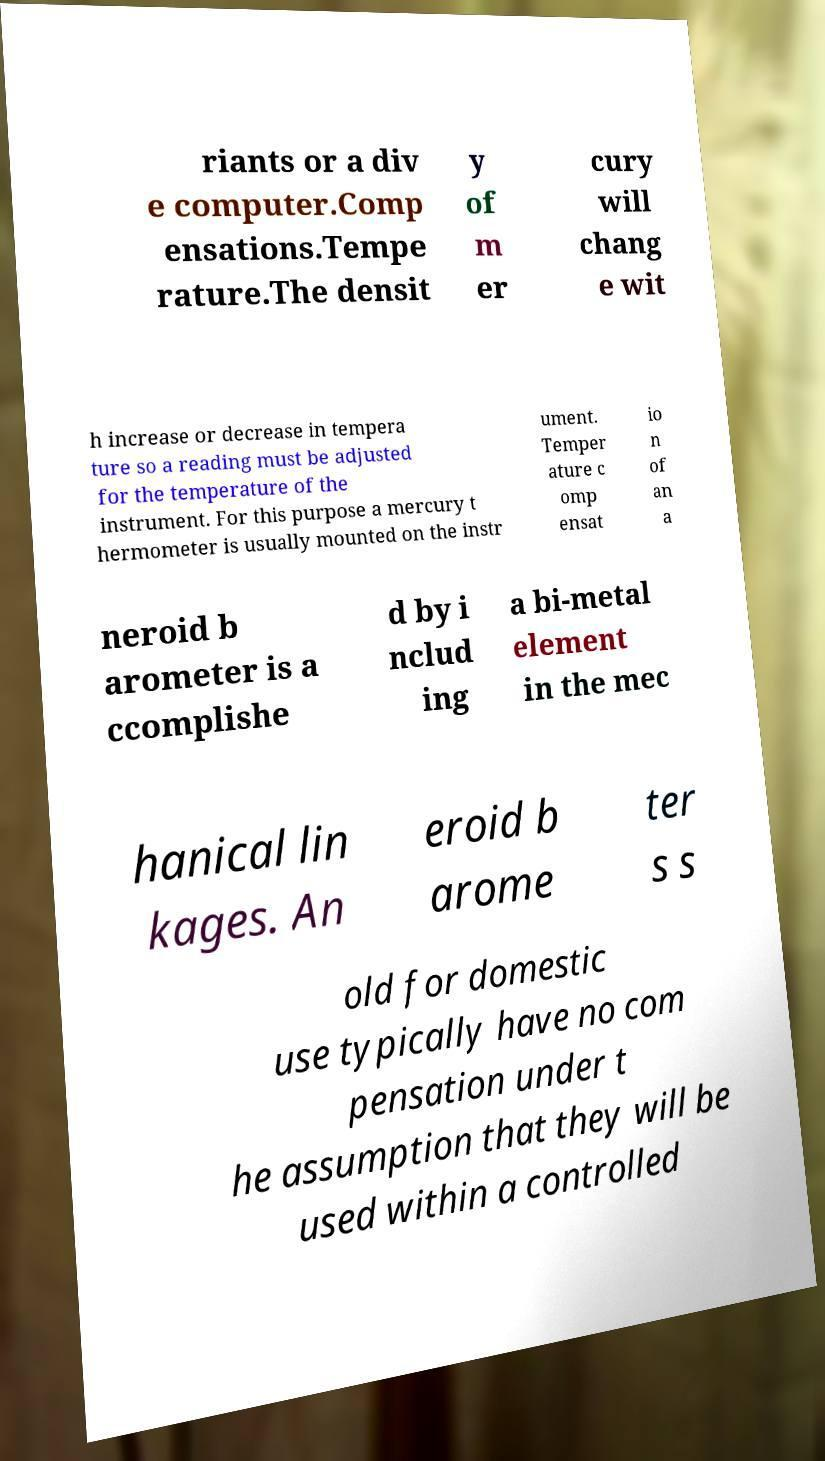Please read and relay the text visible in this image. What does it say? riants or a div e computer.Comp ensations.Tempe rature.The densit y of m er cury will chang e wit h increase or decrease in tempera ture so a reading must be adjusted for the temperature of the instrument. For this purpose a mercury t hermometer is usually mounted on the instr ument. Temper ature c omp ensat io n of an a neroid b arometer is a ccomplishe d by i nclud ing a bi-metal element in the mec hanical lin kages. An eroid b arome ter s s old for domestic use typically have no com pensation under t he assumption that they will be used within a controlled 